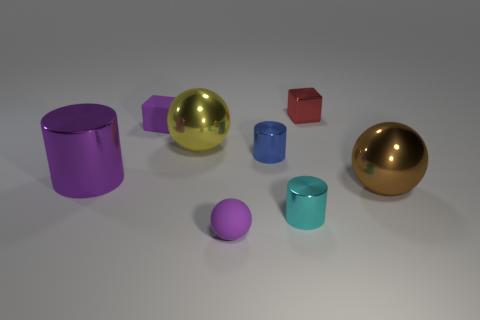Are there any other things that have the same material as the brown sphere?
Keep it short and to the point. Yes. There is a cube that is the same color as the big shiny cylinder; what material is it?
Your answer should be compact. Rubber. What number of shiny objects are behind the large brown thing?
Ensure brevity in your answer.  4. How many purple cylinders have the same material as the cyan thing?
Keep it short and to the point. 1. There is another small cylinder that is made of the same material as the tiny cyan cylinder; what color is it?
Make the answer very short. Blue. What material is the small purple object that is in front of the big sphere in front of the large sphere to the left of the tiny red metal block?
Your answer should be compact. Rubber. Do the cube that is left of the cyan cylinder and the purple metal object have the same size?
Give a very brief answer. No. What number of tiny objects are red rubber balls or blue cylinders?
Your response must be concise. 1. Is there a large metal object that has the same color as the tiny sphere?
Your response must be concise. Yes. What is the shape of the blue shiny object that is the same size as the purple cube?
Offer a terse response. Cylinder. 